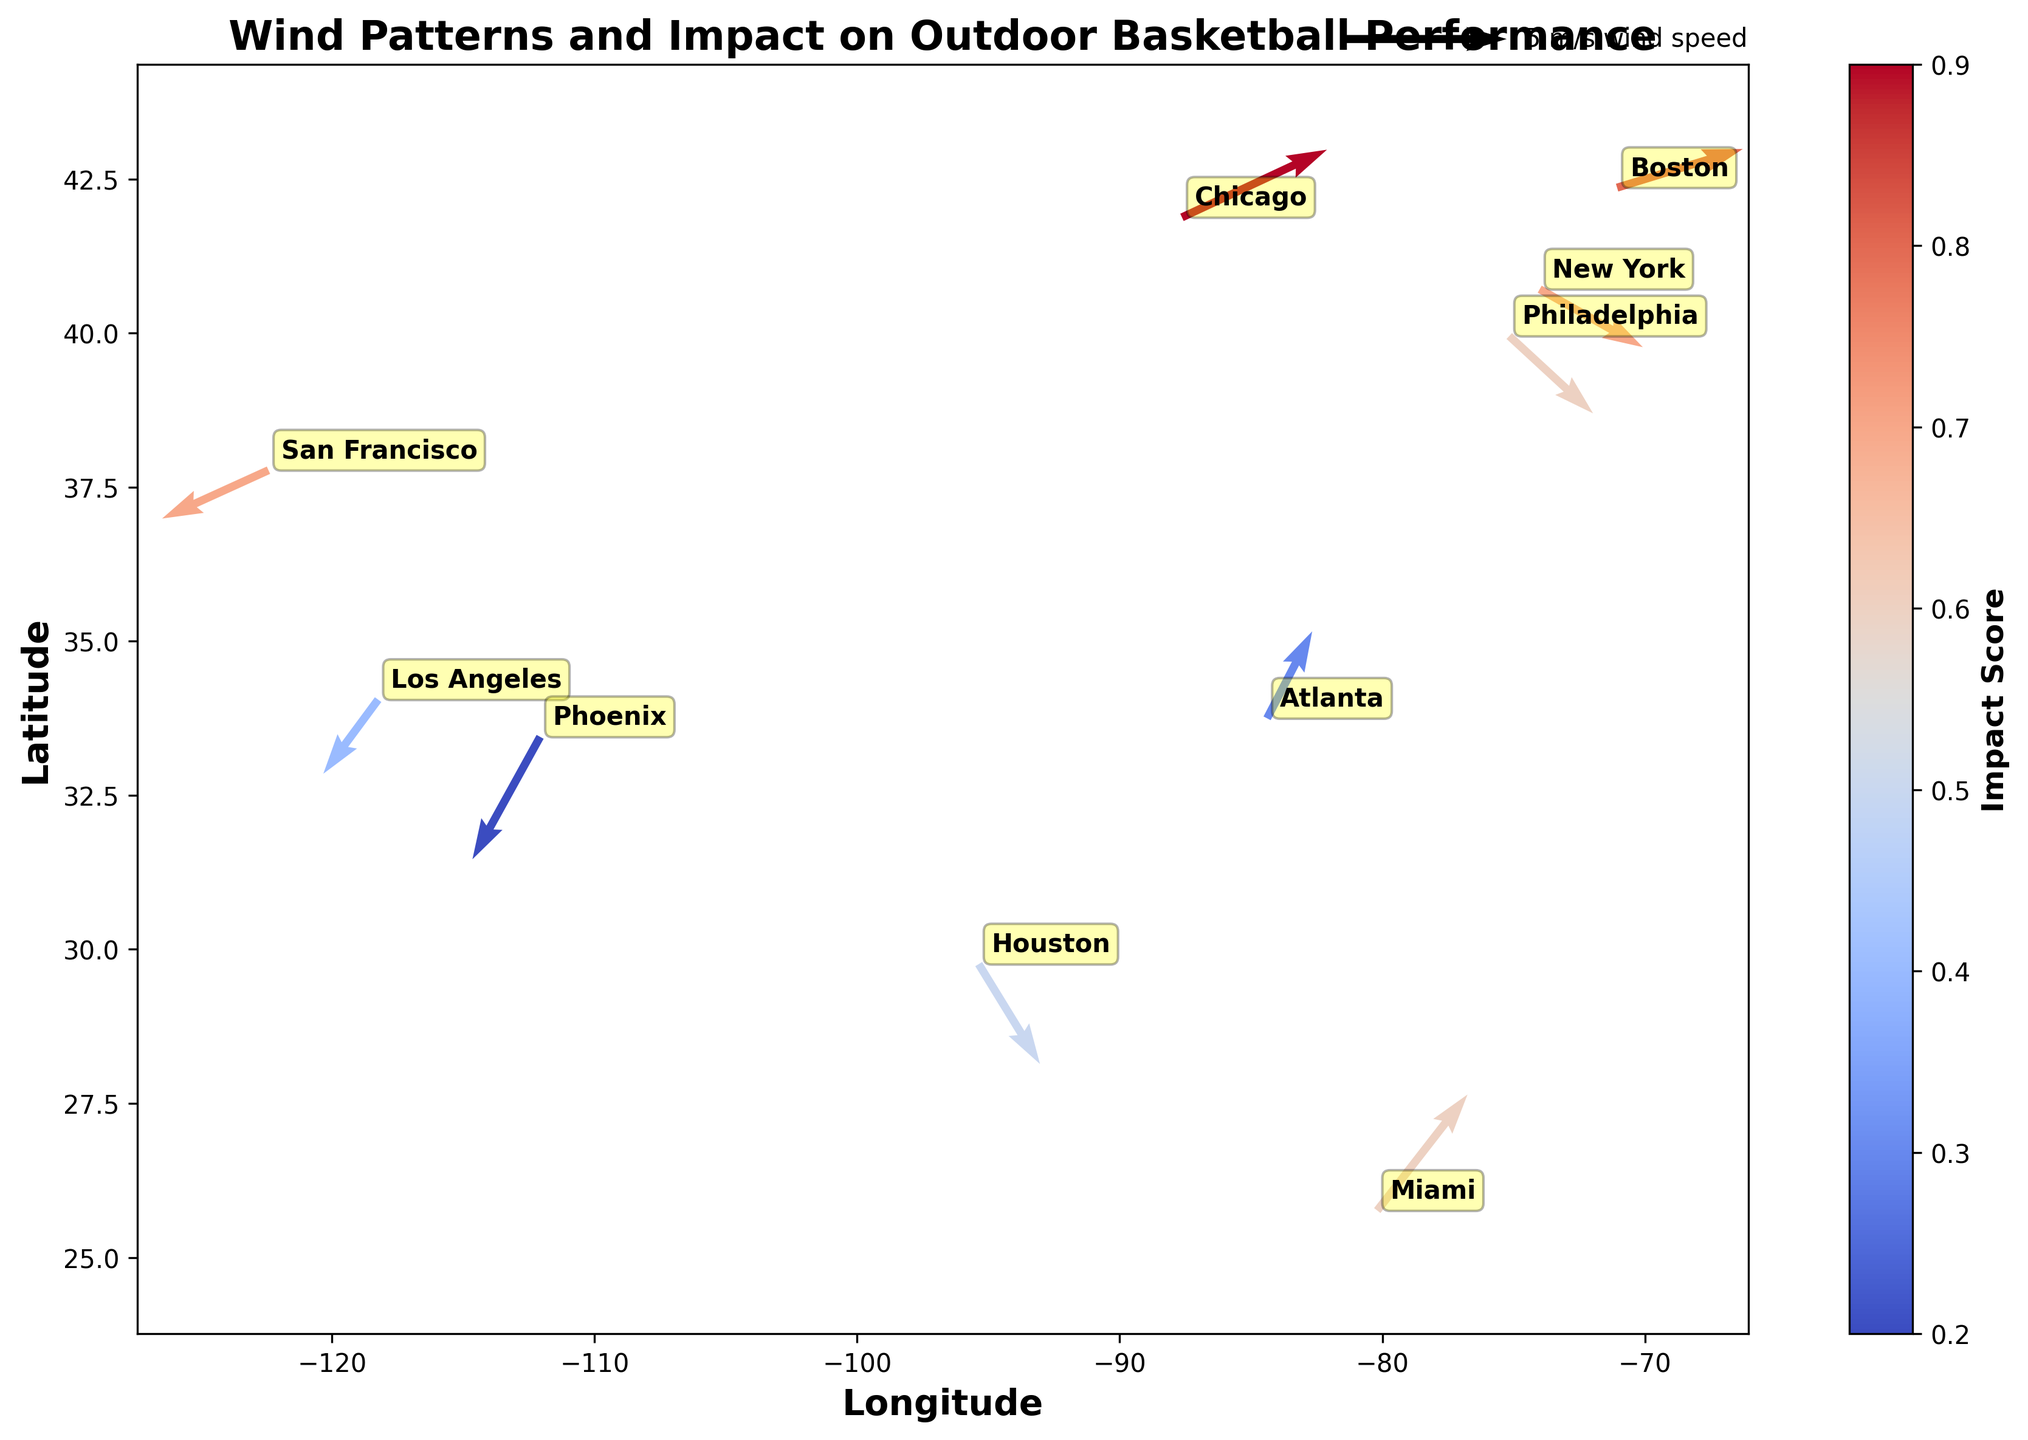What's the title of the figure? The title of the figure is displayed at the top of the plot. It provides a summary of what the figure represents.
Answer: Wind Patterns and Impact on Outdoor Basketball Performance Which city has the highest impact score? By looking at the color intensity associated with each vector, the highest impact score corresponds to the most intense shade. Chicago and Boston show the highest color intensity.
Answer: Chicago and Boston Which city's wind vector is pointing in a downward direction? Downward direction vectors will have a negative Y component. Observing the figure, New York, Philadelphia, and Houston have vectors with negative Y components.
Answer: New York, Philadelphia, and Houston What does the color of the arrows represent? The color of the arrows indicates the impact score. This is highlighted by the colorbar on the side of the figure, showing the scale from cool to warm colors corresponding to different scores.
Answer: Impact Score Which city has a wind vector with both a negative X and Y component? To determine this, look for arrows pointing towards the lower-left (both components are negative). Los Angeles and Phoenix vectors point in that direction.
Answer: Los Angeles and Phoenix How do wind patterns compare between Miami and Phoenix? Miami's vector points upward and to the right (positive X and Y components), while Phoenix's vector points downward and to the left (negative X and Y components).
Answer: Opposite directions What is the wind speed in Chicago compared to New York? The length of the vectors represents wind speed. Comparing the lengths visually, Chicago’s vector is longer than New York’s.
Answer: Chicago has a higher wind speed than New York Which city has the shortest wind vector? The shortest vector indicates the lowest wind speed. In the figure, Phoenix has the shortest arrow.
Answer: Phoenix What general trend can be observed in the wind direction on the west coast (Los Angeles and San Francisco)? Both cities’ vectors point generally towards the southwest, indicating similar wind patterns.
Answer: Southward direction 